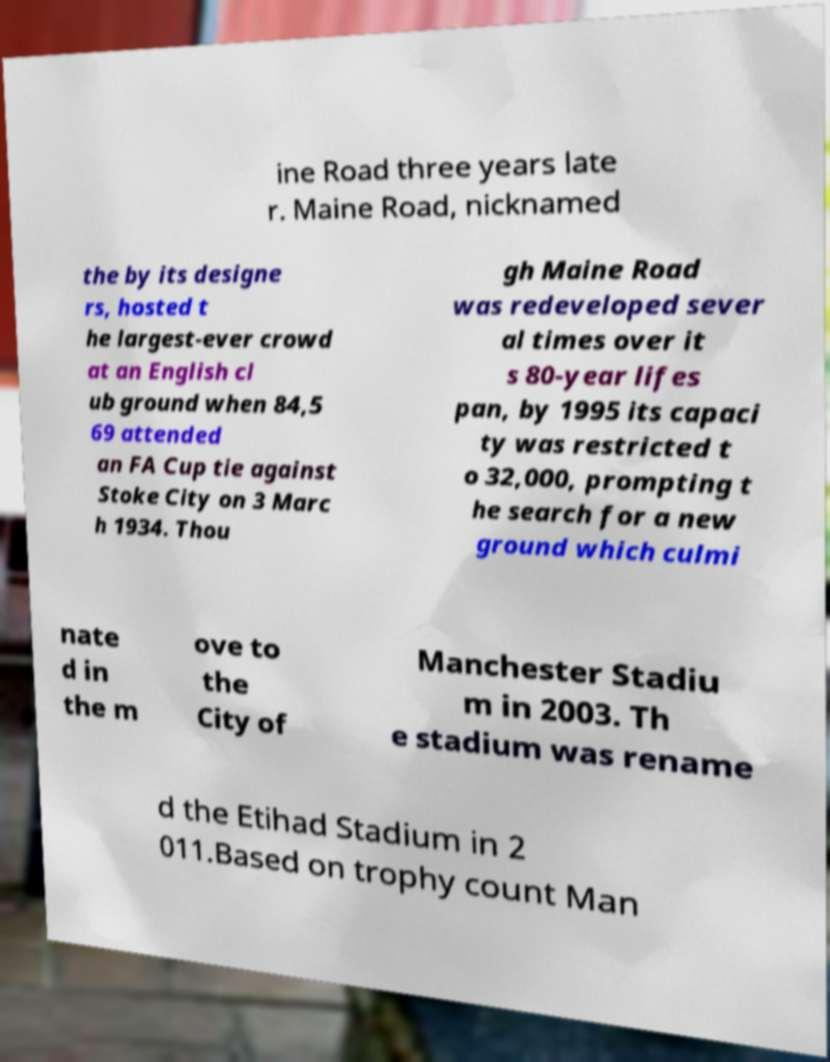Could you assist in decoding the text presented in this image and type it out clearly? ine Road three years late r. Maine Road, nicknamed the by its designe rs, hosted t he largest-ever crowd at an English cl ub ground when 84,5 69 attended an FA Cup tie against Stoke City on 3 Marc h 1934. Thou gh Maine Road was redeveloped sever al times over it s 80-year lifes pan, by 1995 its capaci ty was restricted t o 32,000, prompting t he search for a new ground which culmi nate d in the m ove to the City of Manchester Stadiu m in 2003. Th e stadium was rename d the Etihad Stadium in 2 011.Based on trophy count Man 